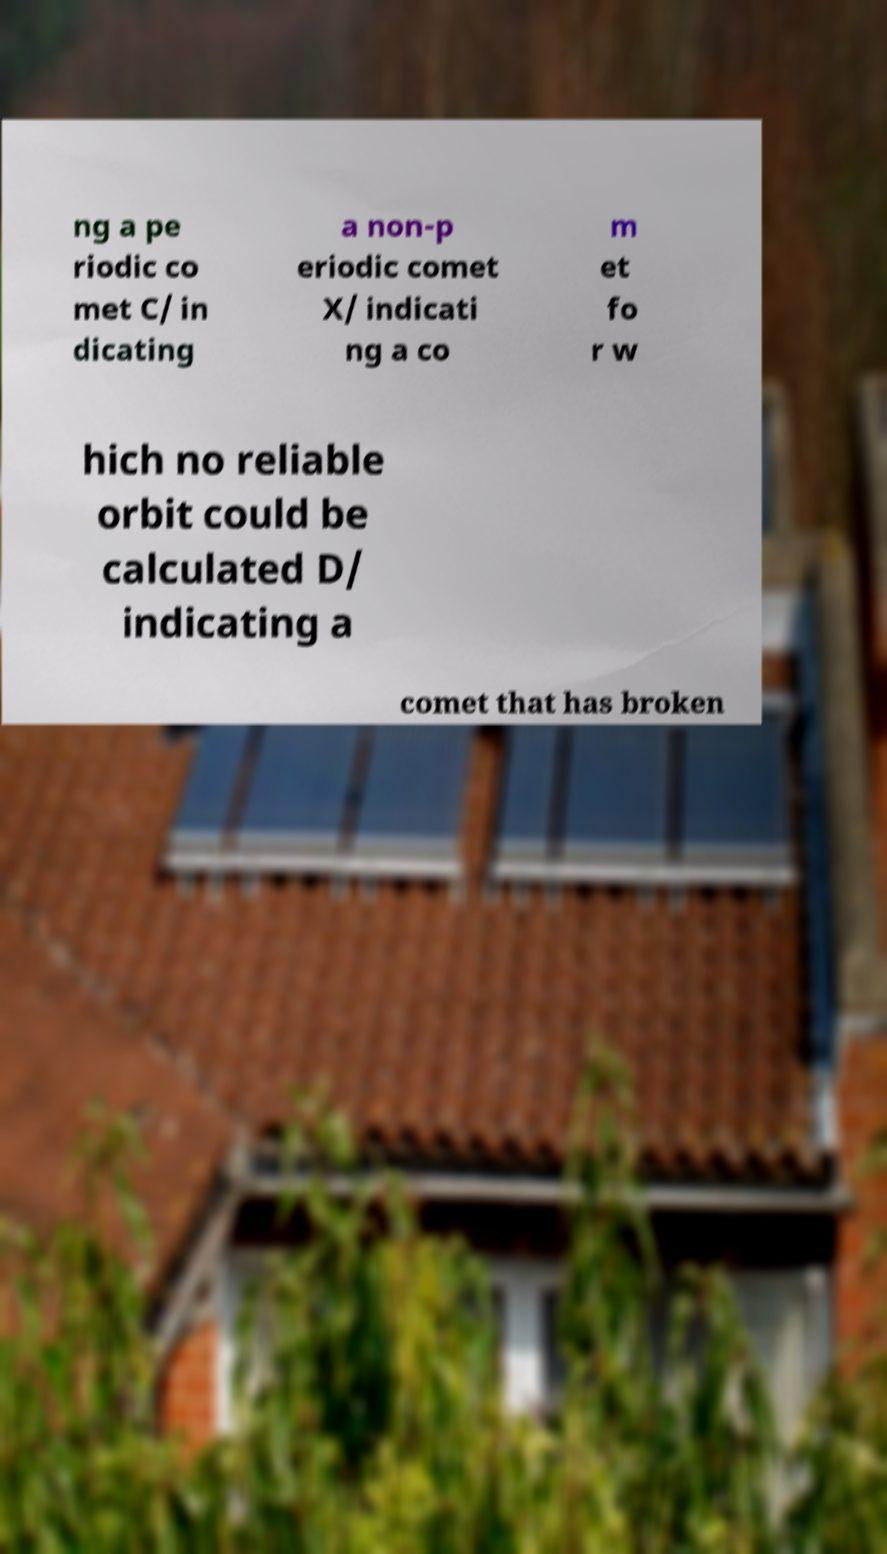Please identify and transcribe the text found in this image. ng a pe riodic co met C/ in dicating a non-p eriodic comet X/ indicati ng a co m et fo r w hich no reliable orbit could be calculated D/ indicating a comet that has broken 